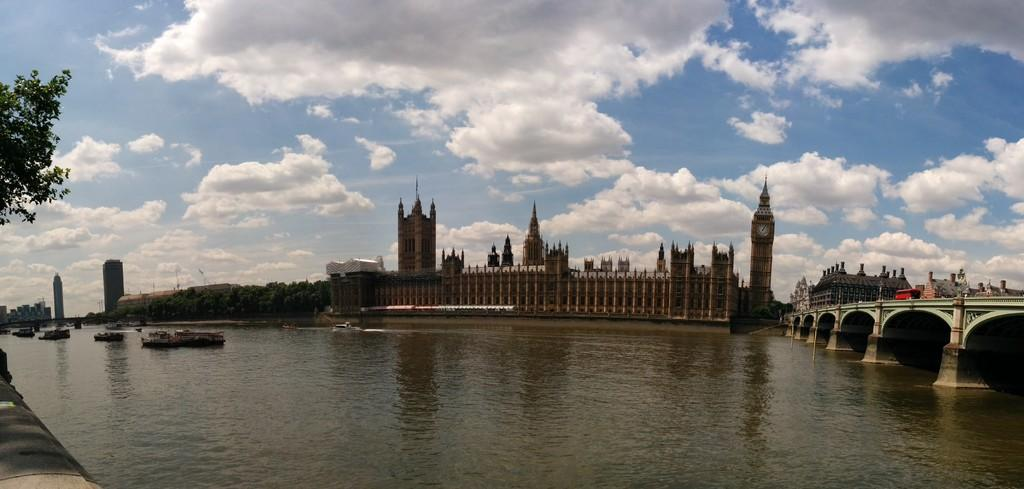What type of body of water is present in the image? There is a lake in the image. What can be seen floating on the lake? There are ships in the image. What type of vegetation is present in the image? There are trees in the image. What structure connects the two sides of the lake? There is a bridge in the image. What type of transportation is present in the image? There are vehicles in the image. What type of structures can be seen in the background of the image? There are buildings in the background of the image. What part of the natural environment is visible in the sky is visible in the image? The sky is visible in the image. What type of weather can be inferred from the image? Clouds are present in the sky, suggesting that it might be a partly cloudy day. Can you see any celery growing near the lake in the image? There is no celery present in the image. How many visitors are standing near the bridge in the image? There is no mention of visitors in the image, so it cannot be determined if any are present. 